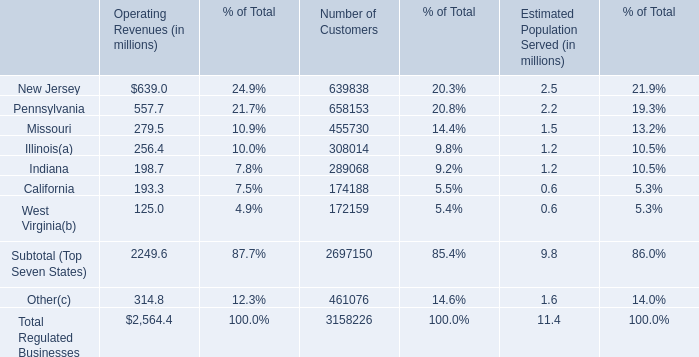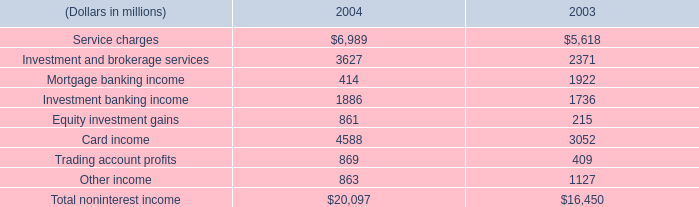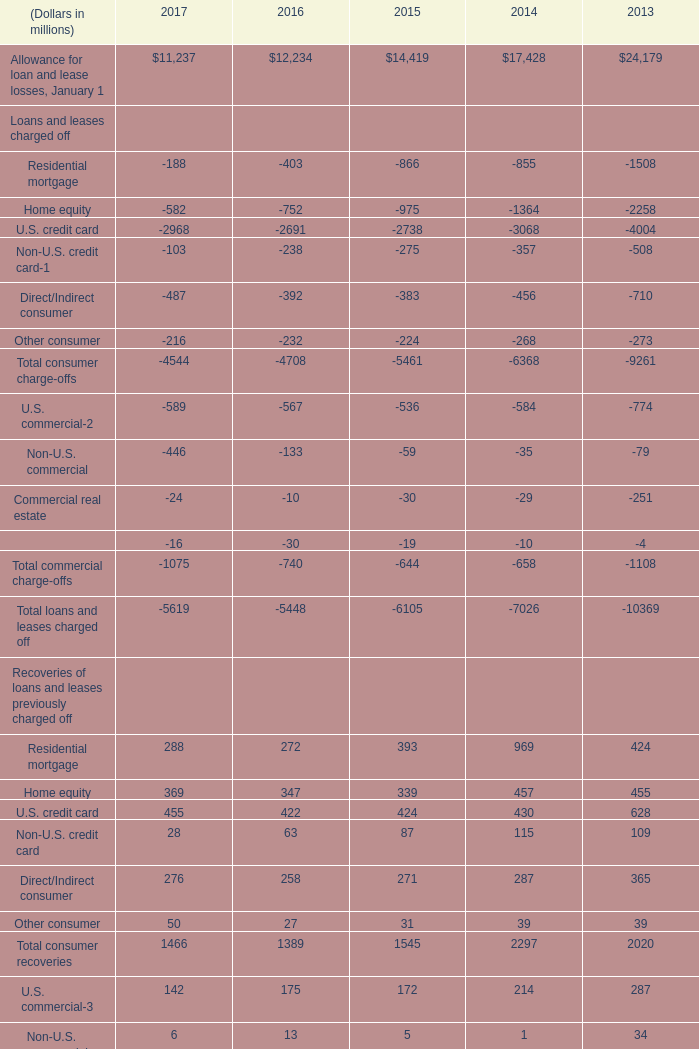Which year is Provision for loan and lease losses the highest? 
Answer: 2016. 